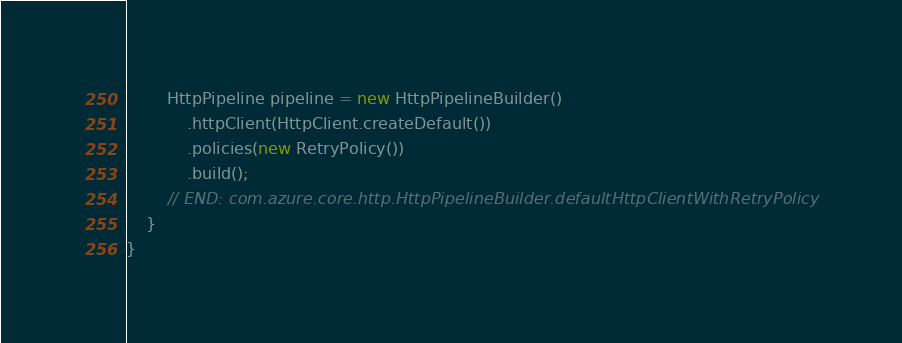Convert code to text. <code><loc_0><loc_0><loc_500><loc_500><_Java_>        HttpPipeline pipeline = new HttpPipelineBuilder()
            .httpClient(HttpClient.createDefault())
            .policies(new RetryPolicy())
            .build();
        // END: com.azure.core.http.HttpPipelineBuilder.defaultHttpClientWithRetryPolicy
    }
}
</code> 